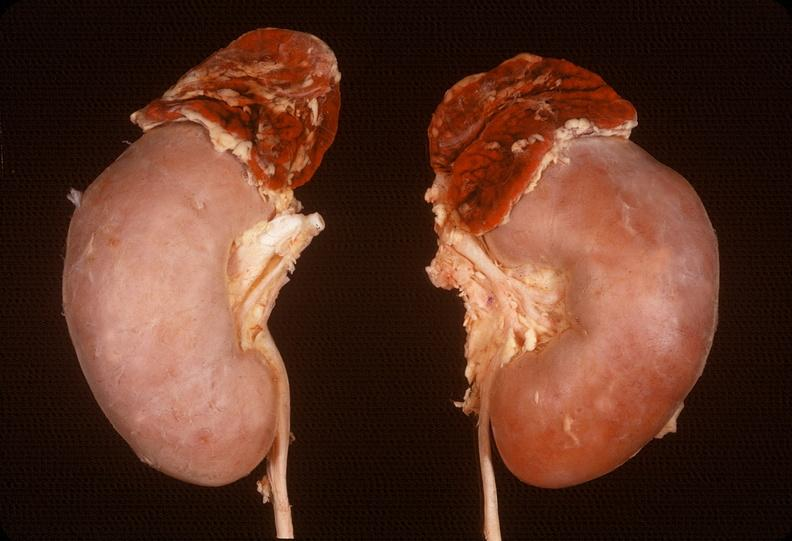does this image show adrenal, hemorrhage?
Answer the question using a single word or phrase. Yes 